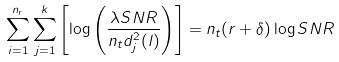<formula> <loc_0><loc_0><loc_500><loc_500>\sum _ { i = 1 } ^ { n _ { r } } \sum _ { j = 1 } ^ { k } \left [ \log \left ( \frac { \lambda S N R } { n _ { t } d _ { j } ^ { 2 } ( l ) } \right ) \right ] = n _ { t } ( r + \delta ) \log S N R</formula> 